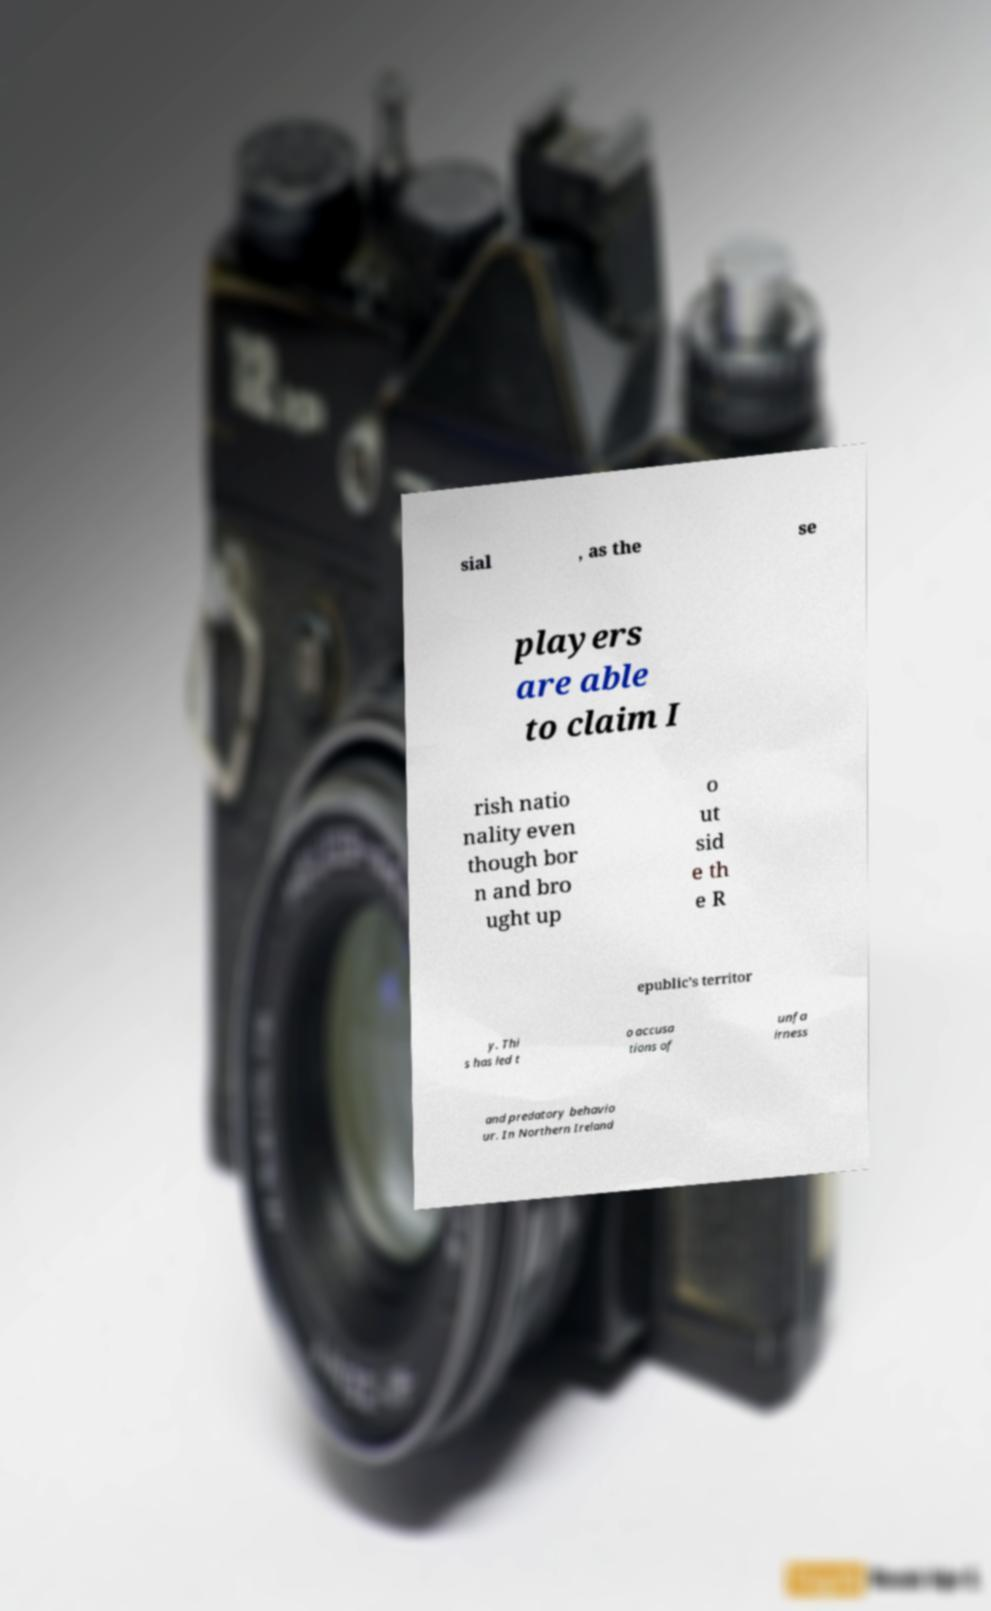I need the written content from this picture converted into text. Can you do that? sial , as the se players are able to claim I rish natio nality even though bor n and bro ught up o ut sid e th e R epublic's territor y. Thi s has led t o accusa tions of unfa irness and predatory behavio ur. In Northern Ireland 